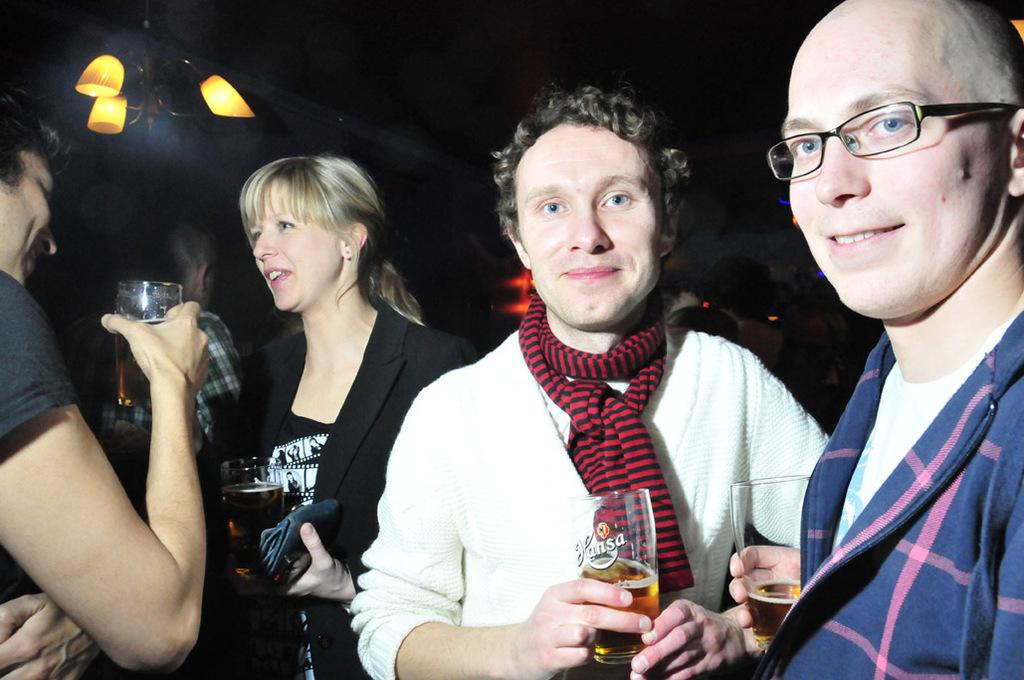How many people are in the image? There are four persons in the image. What are the people holding in their hands? Each of the four persons is holding a glass. Can you describe any accessories or clothing items that are unique to one person? One person is wearing spectacles, one man is wearing a scarf, and one woman is wearing a black suit. What type of bun is the person wearing on their neck in the image? There is no bun or any type of hair accessory visible on anyone's neck in the image. What color is the sweater worn by the person in the image? There is no sweater visible in the image; the clothing items mentioned are a scarf and a black suit. 